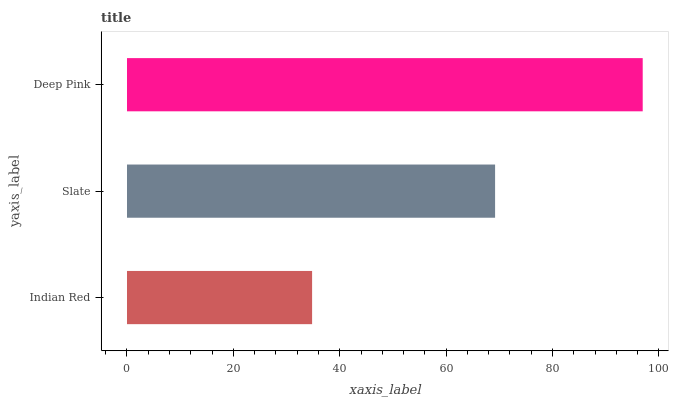Is Indian Red the minimum?
Answer yes or no. Yes. Is Deep Pink the maximum?
Answer yes or no. Yes. Is Slate the minimum?
Answer yes or no. No. Is Slate the maximum?
Answer yes or no. No. Is Slate greater than Indian Red?
Answer yes or no. Yes. Is Indian Red less than Slate?
Answer yes or no. Yes. Is Indian Red greater than Slate?
Answer yes or no. No. Is Slate less than Indian Red?
Answer yes or no. No. Is Slate the high median?
Answer yes or no. Yes. Is Slate the low median?
Answer yes or no. Yes. Is Indian Red the high median?
Answer yes or no. No. Is Indian Red the low median?
Answer yes or no. No. 